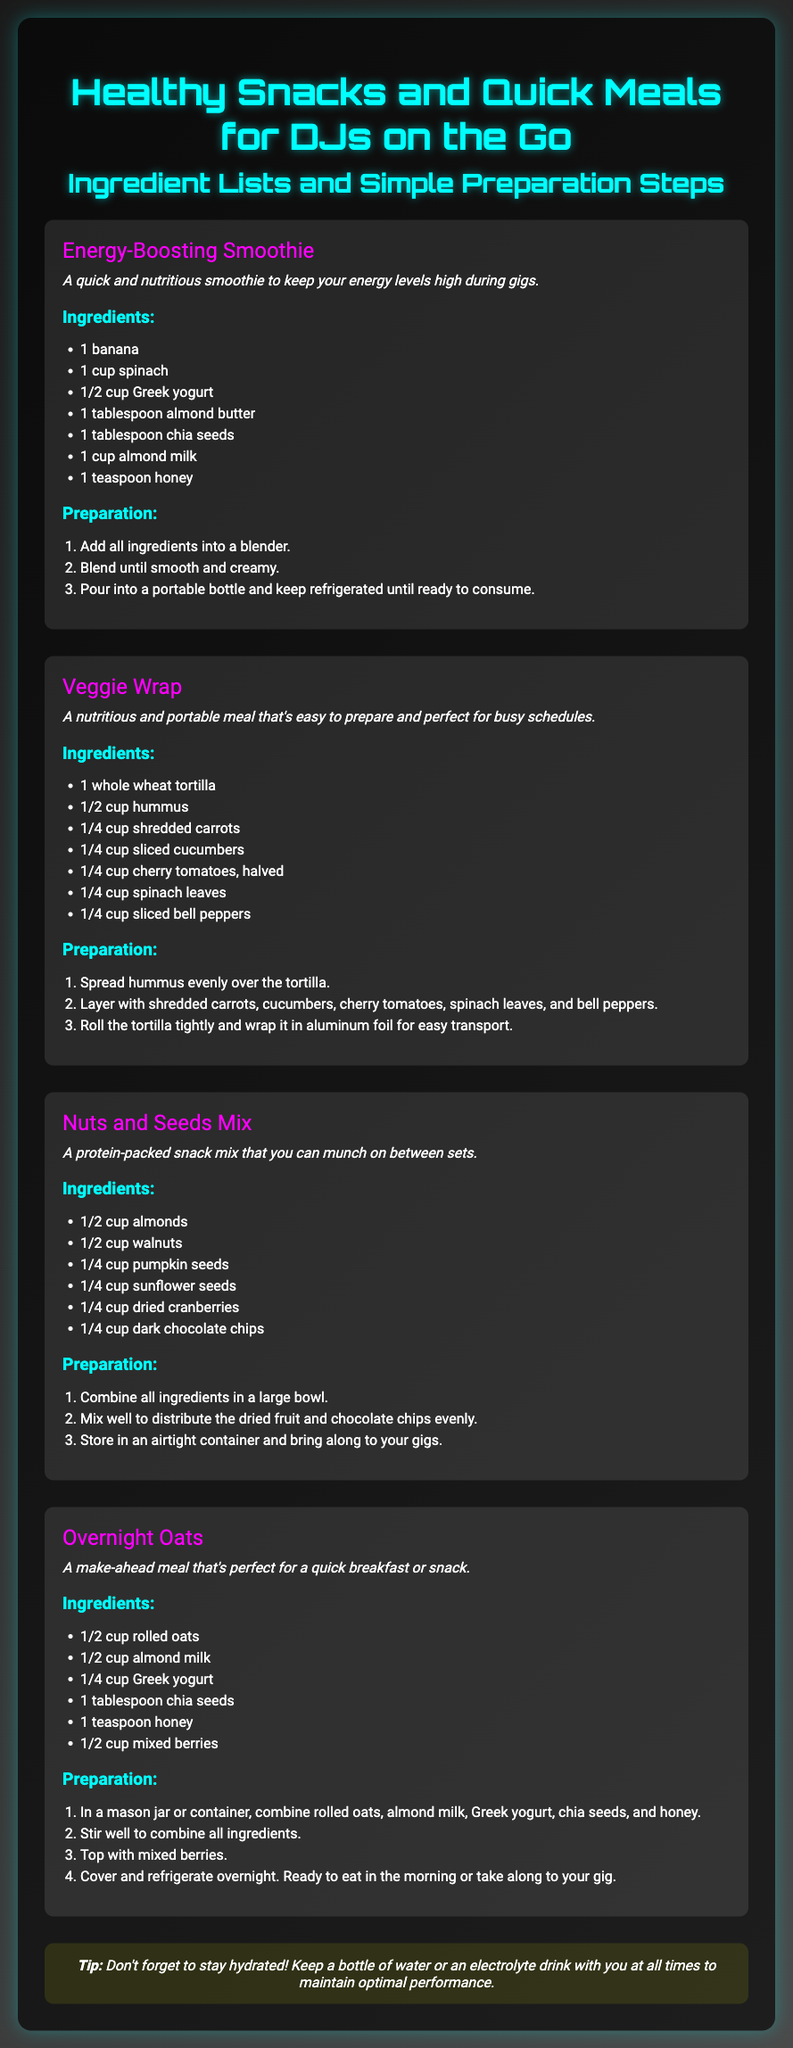What is the first recipe listed? The first recipe listed in the document is "Energy-Boosting Smoothie."
Answer: Energy-Boosting Smoothie How many ingredients are in the Veggie Wrap recipe? The Veggie Wrap recipe includes 7 ingredients as listed in the document.
Answer: 7 What is included in the Nuts and Seeds Mix? The Nuts and Seeds Mix contains almonds, walnuts, pumpkin seeds, sunflower seeds, dried cranberries, and dark chocolate chips.
Answer: almonds, walnuts, pumpkin seeds, sunflower seeds, dried cranberries, dark chocolate chips What is the preparation step for Overnight Oats? The first preparation step for Overnight Oats is to combine rolled oats, almond milk, Greek yogurt, chia seeds, and honey in a jar.
Answer: Combine rolled oats, almond milk, Greek yogurt, chia seeds, and honey Which ingredient is used in all recipes? Upon reviewing the ingredients in all recipes, "chia seeds" is present in the Energy-Boosting Smoothie, Nuts and Seeds Mix, and Overnight Oats.
Answer: chia seeds What quick meal is perfect for a busy schedule? The recipe that mentions being perfect for a busy schedule is the "Veggie Wrap."
Answer: Veggie Wrap What is the advised tip included in the document? The tip advises to stay hydrated and keep a bottle of water or an electrolyte drink with you.
Answer: Stay hydrated! What do you need for an Energy-Boosting Smoothie? You need banana, spinach, Greek yogurt, almond butter, chia seeds, almond milk, and honey for the smoothie.
Answer: banana, spinach, Greek yogurt, almond butter, chia seeds, almond milk, honey 